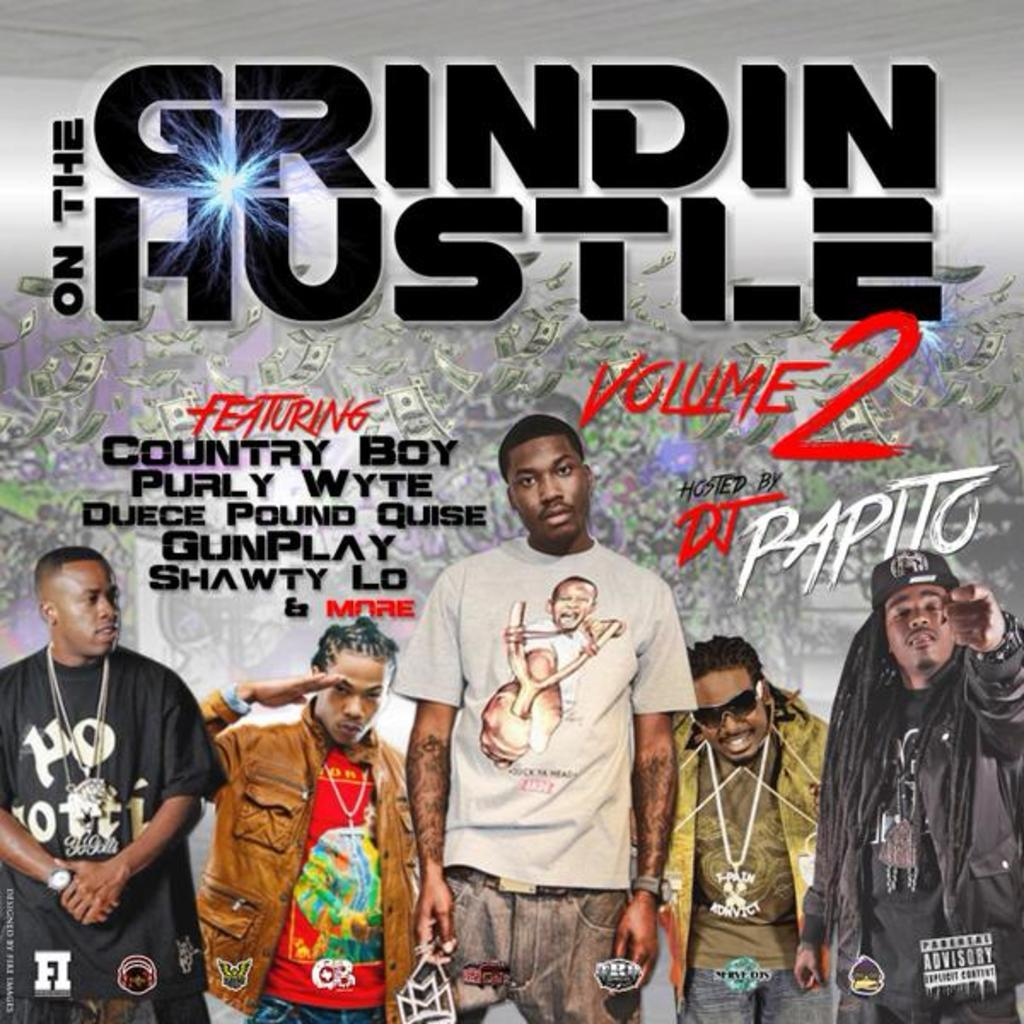What is featured in the image? There is a poster in the image. What can be found on the poster? There is text on the poster. Who or what else is present in the image? There are people in the image. What else can be seen in the image besides the poster and people? There are currency notes in the image. What type of line is being drawn by the son in the image? There is no son present in the image, and therefore no line-drawing activity can be observed. 